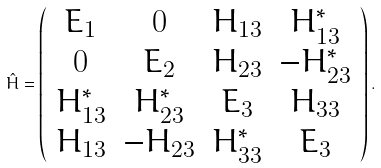Convert formula to latex. <formula><loc_0><loc_0><loc_500><loc_500>\hat { H } = \left ( \begin{array} { c c c c } E _ { 1 } & 0 & H _ { 1 3 } & H _ { 1 3 } ^ { * } \\ 0 & E _ { 2 } & H _ { 2 3 } & - H _ { 2 3 } ^ { * } \\ H _ { 1 3 } ^ { * } & H _ { 2 3 } ^ { * } & E _ { 3 } & H _ { 3 3 } \\ H _ { 1 3 } & - H _ { 2 3 } & H _ { 3 3 } ^ { * } & E _ { 3 } \end{array} \right ) .</formula> 